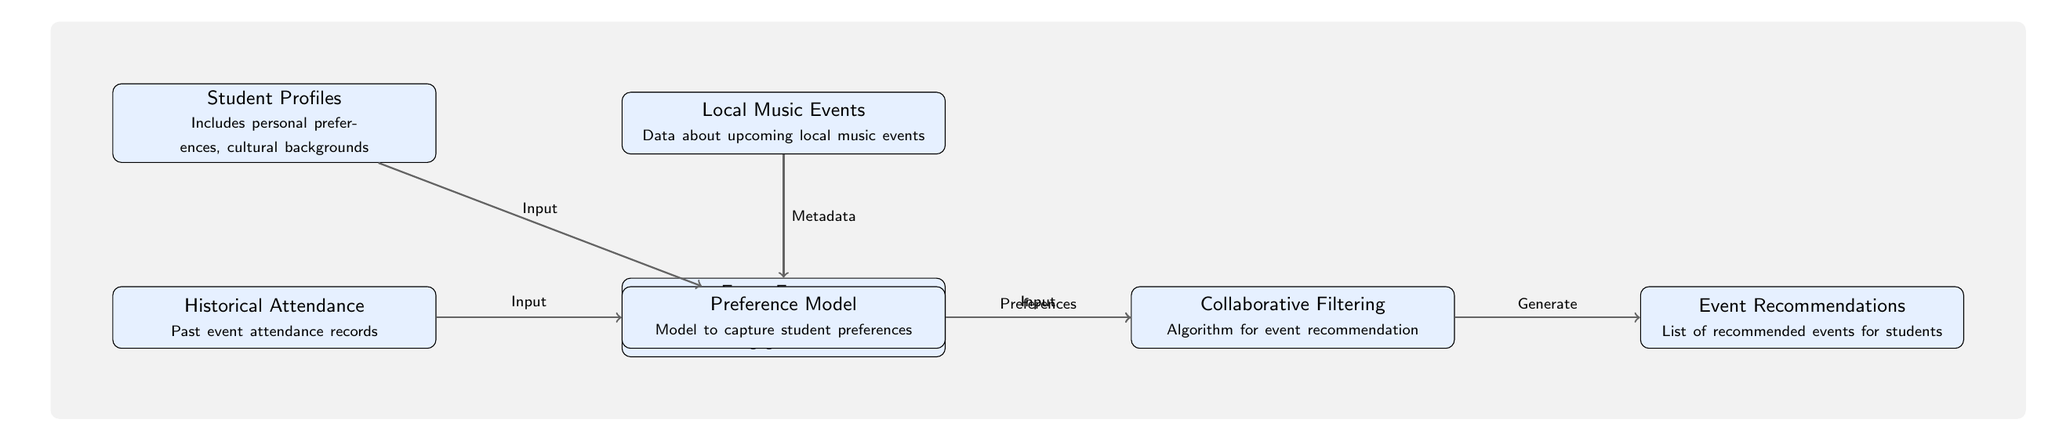What is the first input to the Preference Model? The first input to the Preference Model is the Student Profiles, which are depicted as the top node in the diagram.
Answer: Student Profiles How many nodes are present in the diagram? By counting the individual boxes, there are a total of seven nodes in the diagram.
Answer: Seven What does the Event Recommendations node output? The Event Recommendations node outputs a list of recommended events for students, which is indicated as the final node in the flow.
Answer: List of recommended events for students Which node provides the metadata for the Collaborative Filtering? The metadata for the Collaborative Filtering is provided by the Local Music Events node, which supplies relevant information about upcoming music events.
Answer: Local Music Events What two types of inputs does the Preference Model receive? The Preference Model receives inputs from the Student Profiles and Historical Attendance nodes, which both feed into it before passing their data along.
Answer: Student Profiles and Historical Attendance What is the function of the Collaborative Filtering in the diagram? The Collaborative Filtering serves as an algorithm for event recommendation, capturing the student preferences and relating them to potential events.
Answer: Algorithm for event recommendation Which node is directly connected to Event Features? The node directly connected to Event Features is the Local Music Events, as shown in the diagram's flow of data regarding the events.
Answer: Local Music Events What type of information is included in the Student Profiles node? The Student Profiles node includes information on personal preferences and cultural backgrounds, which are crucial for tailoring event recommendations.
Answer: Personal preferences, cultural backgrounds 